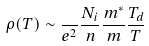Convert formula to latex. <formula><loc_0><loc_0><loc_500><loc_500>\rho ( T ) \sim \frac { } { e ^ { 2 } } \frac { N _ { i } } { n } \frac { m ^ { * } } { m } \frac { T _ { d } } { T }</formula> 